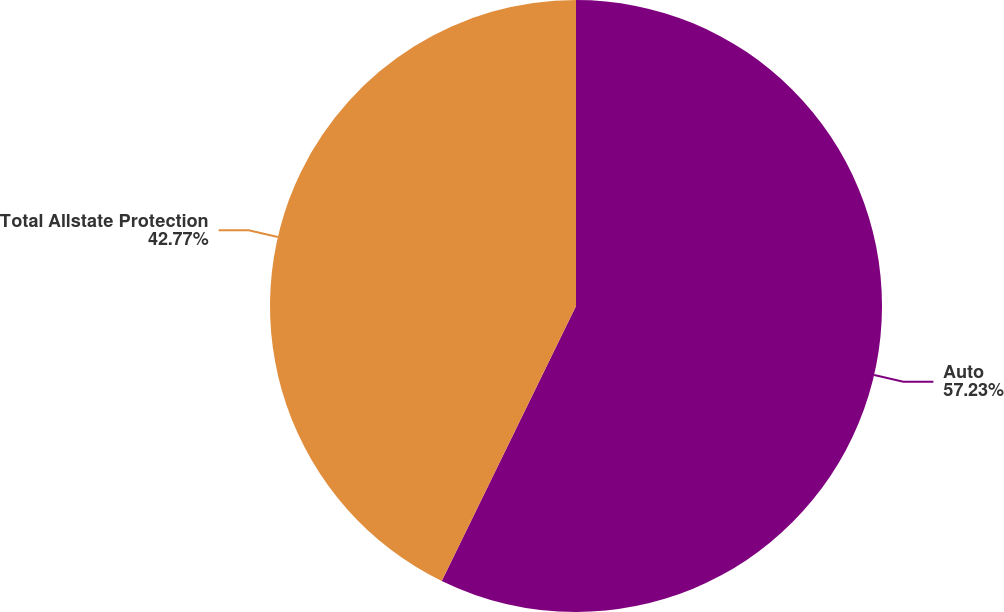<chart> <loc_0><loc_0><loc_500><loc_500><pie_chart><fcel>Auto<fcel>Total Allstate Protection<nl><fcel>57.23%<fcel>42.77%<nl></chart> 